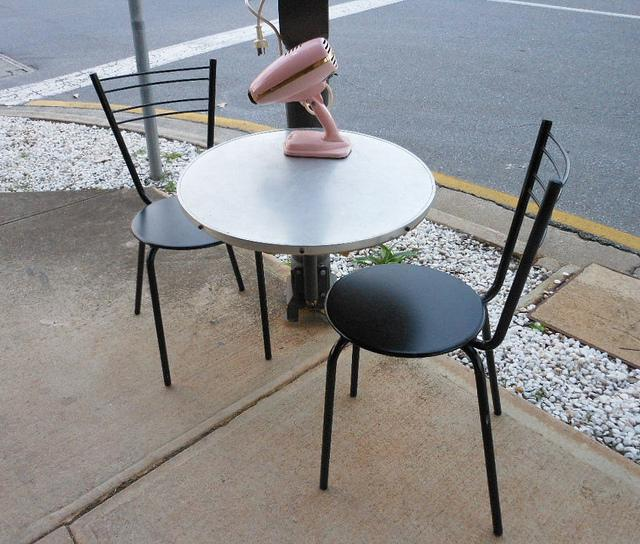What type of electronic is on the table?

Choices:
A) phone
B) hair dryer
C) fan
D) vacuum hair dryer 